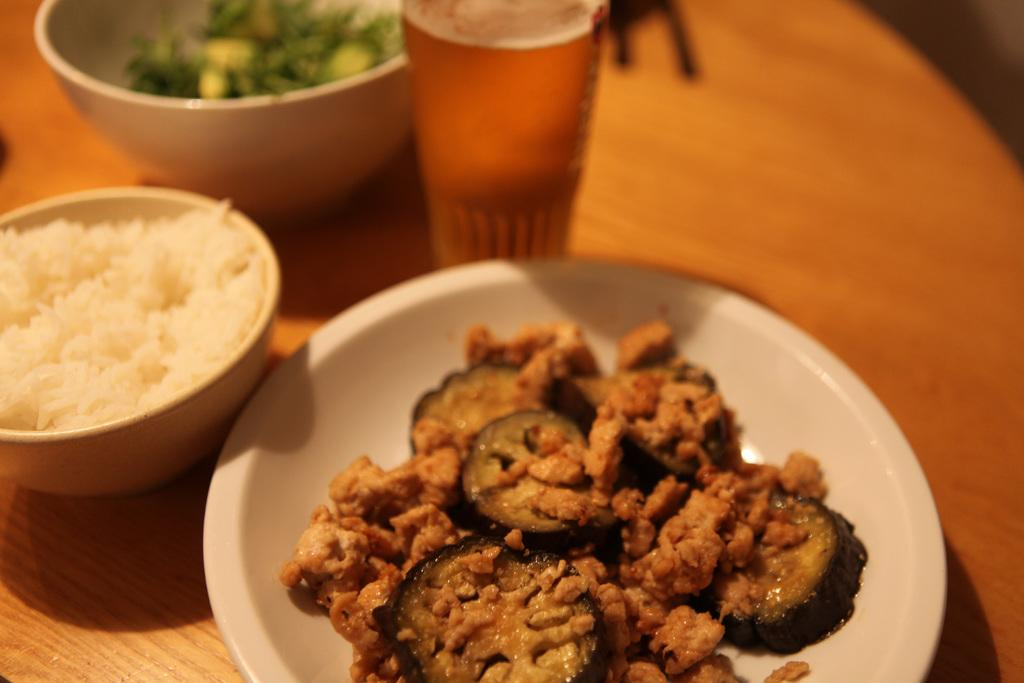What type of objects are present on the surface in the image? There are plates with food, bowls with food, and a glass in the image. What color is the surface on which the objects are placed? The surface is brown in color. What can be used for drinking in the image? There is a glass in the image that can be used for drinking. How would you describe the background of the image? The background of the image is blurred. What is the opinion of the ink on the plates in the image? There is no ink present in the image, so it is not possible to determine its opinion. 